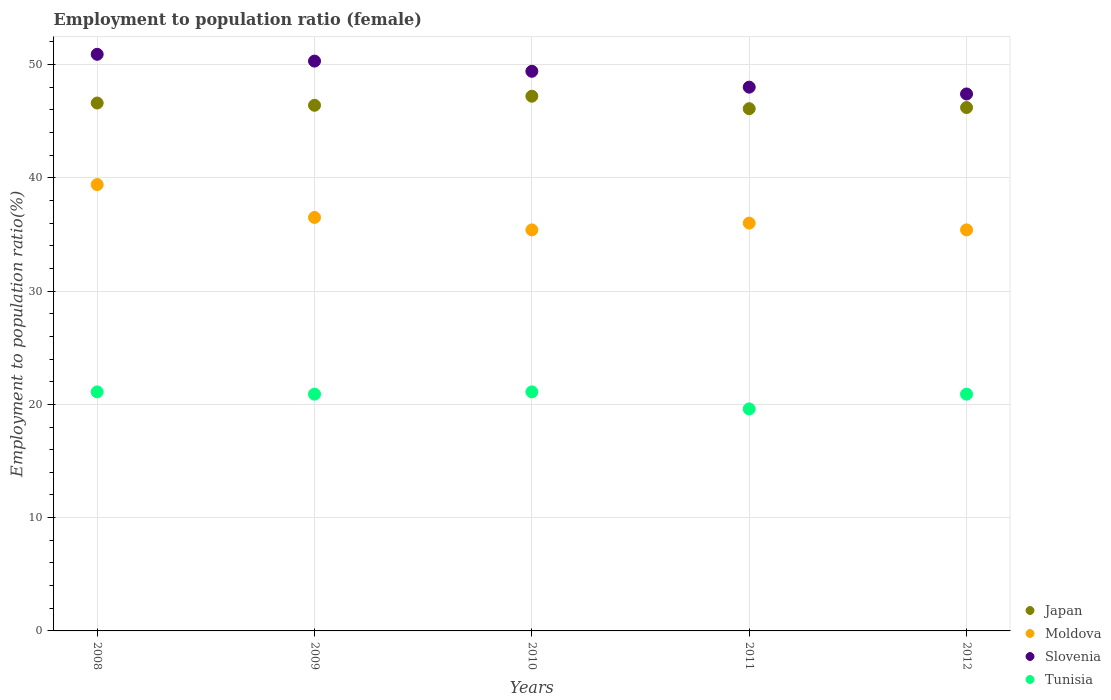What is the employment to population ratio in Slovenia in 2009?
Provide a succinct answer. 50.3. Across all years, what is the maximum employment to population ratio in Tunisia?
Your answer should be very brief. 21.1. Across all years, what is the minimum employment to population ratio in Slovenia?
Your answer should be very brief. 47.4. What is the total employment to population ratio in Moldova in the graph?
Your answer should be very brief. 182.7. What is the difference between the employment to population ratio in Slovenia in 2010 and the employment to population ratio in Japan in 2012?
Ensure brevity in your answer.  3.2. What is the average employment to population ratio in Slovenia per year?
Keep it short and to the point. 49.2. In the year 2011, what is the difference between the employment to population ratio in Japan and employment to population ratio in Slovenia?
Keep it short and to the point. -1.9. What is the ratio of the employment to population ratio in Tunisia in 2008 to that in 2010?
Provide a succinct answer. 1. What is the difference between the highest and the second highest employment to population ratio in Slovenia?
Make the answer very short. 0.6. Is the sum of the employment to population ratio in Slovenia in 2009 and 2011 greater than the maximum employment to population ratio in Japan across all years?
Offer a very short reply. Yes. Is it the case that in every year, the sum of the employment to population ratio in Moldova and employment to population ratio in Tunisia  is greater than the employment to population ratio in Slovenia?
Offer a very short reply. Yes. What is the difference between two consecutive major ticks on the Y-axis?
Ensure brevity in your answer.  10. Does the graph contain any zero values?
Your answer should be compact. No. Where does the legend appear in the graph?
Your response must be concise. Bottom right. What is the title of the graph?
Keep it short and to the point. Employment to population ratio (female). Does "Georgia" appear as one of the legend labels in the graph?
Your answer should be compact. No. What is the label or title of the Y-axis?
Give a very brief answer. Employment to population ratio(%). What is the Employment to population ratio(%) of Japan in 2008?
Provide a succinct answer. 46.6. What is the Employment to population ratio(%) of Moldova in 2008?
Keep it short and to the point. 39.4. What is the Employment to population ratio(%) of Slovenia in 2008?
Make the answer very short. 50.9. What is the Employment to population ratio(%) in Tunisia in 2008?
Keep it short and to the point. 21.1. What is the Employment to population ratio(%) of Japan in 2009?
Keep it short and to the point. 46.4. What is the Employment to population ratio(%) in Moldova in 2009?
Make the answer very short. 36.5. What is the Employment to population ratio(%) of Slovenia in 2009?
Your answer should be compact. 50.3. What is the Employment to population ratio(%) of Tunisia in 2009?
Offer a very short reply. 20.9. What is the Employment to population ratio(%) in Japan in 2010?
Ensure brevity in your answer.  47.2. What is the Employment to population ratio(%) in Moldova in 2010?
Your answer should be compact. 35.4. What is the Employment to population ratio(%) in Slovenia in 2010?
Ensure brevity in your answer.  49.4. What is the Employment to population ratio(%) in Tunisia in 2010?
Ensure brevity in your answer.  21.1. What is the Employment to population ratio(%) in Japan in 2011?
Your answer should be compact. 46.1. What is the Employment to population ratio(%) of Slovenia in 2011?
Give a very brief answer. 48. What is the Employment to population ratio(%) of Tunisia in 2011?
Offer a terse response. 19.6. What is the Employment to population ratio(%) of Japan in 2012?
Offer a terse response. 46.2. What is the Employment to population ratio(%) in Moldova in 2012?
Keep it short and to the point. 35.4. What is the Employment to population ratio(%) in Slovenia in 2012?
Your response must be concise. 47.4. What is the Employment to population ratio(%) in Tunisia in 2012?
Offer a very short reply. 20.9. Across all years, what is the maximum Employment to population ratio(%) of Japan?
Make the answer very short. 47.2. Across all years, what is the maximum Employment to population ratio(%) in Moldova?
Ensure brevity in your answer.  39.4. Across all years, what is the maximum Employment to population ratio(%) in Slovenia?
Keep it short and to the point. 50.9. Across all years, what is the maximum Employment to population ratio(%) in Tunisia?
Your answer should be compact. 21.1. Across all years, what is the minimum Employment to population ratio(%) of Japan?
Your answer should be compact. 46.1. Across all years, what is the minimum Employment to population ratio(%) in Moldova?
Ensure brevity in your answer.  35.4. Across all years, what is the minimum Employment to population ratio(%) in Slovenia?
Provide a succinct answer. 47.4. Across all years, what is the minimum Employment to population ratio(%) of Tunisia?
Offer a terse response. 19.6. What is the total Employment to population ratio(%) in Japan in the graph?
Give a very brief answer. 232.5. What is the total Employment to population ratio(%) of Moldova in the graph?
Provide a short and direct response. 182.7. What is the total Employment to population ratio(%) in Slovenia in the graph?
Provide a short and direct response. 246. What is the total Employment to population ratio(%) in Tunisia in the graph?
Offer a very short reply. 103.6. What is the difference between the Employment to population ratio(%) in Moldova in 2008 and that in 2009?
Make the answer very short. 2.9. What is the difference between the Employment to population ratio(%) of Tunisia in 2008 and that in 2009?
Your response must be concise. 0.2. What is the difference between the Employment to population ratio(%) of Moldova in 2008 and that in 2010?
Your answer should be very brief. 4. What is the difference between the Employment to population ratio(%) in Slovenia in 2008 and that in 2010?
Provide a short and direct response. 1.5. What is the difference between the Employment to population ratio(%) in Moldova in 2008 and that in 2011?
Provide a succinct answer. 3.4. What is the difference between the Employment to population ratio(%) in Moldova in 2009 and that in 2010?
Offer a terse response. 1.1. What is the difference between the Employment to population ratio(%) of Moldova in 2009 and that in 2011?
Give a very brief answer. 0.5. What is the difference between the Employment to population ratio(%) in Slovenia in 2009 and that in 2011?
Ensure brevity in your answer.  2.3. What is the difference between the Employment to population ratio(%) of Tunisia in 2009 and that in 2011?
Ensure brevity in your answer.  1.3. What is the difference between the Employment to population ratio(%) of Moldova in 2009 and that in 2012?
Offer a terse response. 1.1. What is the difference between the Employment to population ratio(%) of Slovenia in 2009 and that in 2012?
Keep it short and to the point. 2.9. What is the difference between the Employment to population ratio(%) in Tunisia in 2009 and that in 2012?
Your response must be concise. 0. What is the difference between the Employment to population ratio(%) in Japan in 2010 and that in 2011?
Make the answer very short. 1.1. What is the difference between the Employment to population ratio(%) in Moldova in 2010 and that in 2011?
Give a very brief answer. -0.6. What is the difference between the Employment to population ratio(%) of Slovenia in 2010 and that in 2011?
Provide a succinct answer. 1.4. What is the difference between the Employment to population ratio(%) in Slovenia in 2010 and that in 2012?
Provide a succinct answer. 2. What is the difference between the Employment to population ratio(%) of Tunisia in 2010 and that in 2012?
Keep it short and to the point. 0.2. What is the difference between the Employment to population ratio(%) in Japan in 2011 and that in 2012?
Make the answer very short. -0.1. What is the difference between the Employment to population ratio(%) in Japan in 2008 and the Employment to population ratio(%) in Moldova in 2009?
Give a very brief answer. 10.1. What is the difference between the Employment to population ratio(%) of Japan in 2008 and the Employment to population ratio(%) of Tunisia in 2009?
Offer a very short reply. 25.7. What is the difference between the Employment to population ratio(%) in Moldova in 2008 and the Employment to population ratio(%) in Tunisia in 2009?
Your response must be concise. 18.5. What is the difference between the Employment to population ratio(%) in Slovenia in 2008 and the Employment to population ratio(%) in Tunisia in 2009?
Ensure brevity in your answer.  30. What is the difference between the Employment to population ratio(%) in Japan in 2008 and the Employment to population ratio(%) in Slovenia in 2010?
Offer a very short reply. -2.8. What is the difference between the Employment to population ratio(%) of Japan in 2008 and the Employment to population ratio(%) of Tunisia in 2010?
Offer a very short reply. 25.5. What is the difference between the Employment to population ratio(%) of Moldova in 2008 and the Employment to population ratio(%) of Tunisia in 2010?
Make the answer very short. 18.3. What is the difference between the Employment to population ratio(%) of Slovenia in 2008 and the Employment to population ratio(%) of Tunisia in 2010?
Your answer should be compact. 29.8. What is the difference between the Employment to population ratio(%) of Japan in 2008 and the Employment to population ratio(%) of Moldova in 2011?
Your response must be concise. 10.6. What is the difference between the Employment to population ratio(%) of Japan in 2008 and the Employment to population ratio(%) of Slovenia in 2011?
Ensure brevity in your answer.  -1.4. What is the difference between the Employment to population ratio(%) in Japan in 2008 and the Employment to population ratio(%) in Tunisia in 2011?
Your answer should be compact. 27. What is the difference between the Employment to population ratio(%) in Moldova in 2008 and the Employment to population ratio(%) in Tunisia in 2011?
Keep it short and to the point. 19.8. What is the difference between the Employment to population ratio(%) of Slovenia in 2008 and the Employment to population ratio(%) of Tunisia in 2011?
Offer a terse response. 31.3. What is the difference between the Employment to population ratio(%) of Japan in 2008 and the Employment to population ratio(%) of Slovenia in 2012?
Offer a very short reply. -0.8. What is the difference between the Employment to population ratio(%) in Japan in 2008 and the Employment to population ratio(%) in Tunisia in 2012?
Ensure brevity in your answer.  25.7. What is the difference between the Employment to population ratio(%) of Moldova in 2008 and the Employment to population ratio(%) of Slovenia in 2012?
Your answer should be compact. -8. What is the difference between the Employment to population ratio(%) of Moldova in 2008 and the Employment to population ratio(%) of Tunisia in 2012?
Give a very brief answer. 18.5. What is the difference between the Employment to population ratio(%) in Slovenia in 2008 and the Employment to population ratio(%) in Tunisia in 2012?
Ensure brevity in your answer.  30. What is the difference between the Employment to population ratio(%) of Japan in 2009 and the Employment to population ratio(%) of Slovenia in 2010?
Provide a succinct answer. -3. What is the difference between the Employment to population ratio(%) of Japan in 2009 and the Employment to population ratio(%) of Tunisia in 2010?
Provide a short and direct response. 25.3. What is the difference between the Employment to population ratio(%) of Moldova in 2009 and the Employment to population ratio(%) of Tunisia in 2010?
Provide a succinct answer. 15.4. What is the difference between the Employment to population ratio(%) of Slovenia in 2009 and the Employment to population ratio(%) of Tunisia in 2010?
Ensure brevity in your answer.  29.2. What is the difference between the Employment to population ratio(%) in Japan in 2009 and the Employment to population ratio(%) in Slovenia in 2011?
Your answer should be compact. -1.6. What is the difference between the Employment to population ratio(%) in Japan in 2009 and the Employment to population ratio(%) in Tunisia in 2011?
Offer a terse response. 26.8. What is the difference between the Employment to population ratio(%) of Moldova in 2009 and the Employment to population ratio(%) of Slovenia in 2011?
Provide a short and direct response. -11.5. What is the difference between the Employment to population ratio(%) of Moldova in 2009 and the Employment to population ratio(%) of Tunisia in 2011?
Your response must be concise. 16.9. What is the difference between the Employment to population ratio(%) of Slovenia in 2009 and the Employment to population ratio(%) of Tunisia in 2011?
Give a very brief answer. 30.7. What is the difference between the Employment to population ratio(%) in Japan in 2009 and the Employment to population ratio(%) in Slovenia in 2012?
Your answer should be very brief. -1. What is the difference between the Employment to population ratio(%) of Japan in 2009 and the Employment to population ratio(%) of Tunisia in 2012?
Offer a terse response. 25.5. What is the difference between the Employment to population ratio(%) of Moldova in 2009 and the Employment to population ratio(%) of Slovenia in 2012?
Give a very brief answer. -10.9. What is the difference between the Employment to population ratio(%) in Slovenia in 2009 and the Employment to population ratio(%) in Tunisia in 2012?
Your response must be concise. 29.4. What is the difference between the Employment to population ratio(%) of Japan in 2010 and the Employment to population ratio(%) of Moldova in 2011?
Give a very brief answer. 11.2. What is the difference between the Employment to population ratio(%) in Japan in 2010 and the Employment to population ratio(%) in Slovenia in 2011?
Provide a succinct answer. -0.8. What is the difference between the Employment to population ratio(%) of Japan in 2010 and the Employment to population ratio(%) of Tunisia in 2011?
Offer a terse response. 27.6. What is the difference between the Employment to population ratio(%) in Slovenia in 2010 and the Employment to population ratio(%) in Tunisia in 2011?
Make the answer very short. 29.8. What is the difference between the Employment to population ratio(%) in Japan in 2010 and the Employment to population ratio(%) in Tunisia in 2012?
Your response must be concise. 26.3. What is the difference between the Employment to population ratio(%) of Moldova in 2010 and the Employment to population ratio(%) of Slovenia in 2012?
Give a very brief answer. -12. What is the difference between the Employment to population ratio(%) in Slovenia in 2010 and the Employment to population ratio(%) in Tunisia in 2012?
Provide a short and direct response. 28.5. What is the difference between the Employment to population ratio(%) of Japan in 2011 and the Employment to population ratio(%) of Tunisia in 2012?
Provide a succinct answer. 25.2. What is the difference between the Employment to population ratio(%) in Moldova in 2011 and the Employment to population ratio(%) in Slovenia in 2012?
Offer a very short reply. -11.4. What is the difference between the Employment to population ratio(%) of Moldova in 2011 and the Employment to population ratio(%) of Tunisia in 2012?
Your answer should be very brief. 15.1. What is the difference between the Employment to population ratio(%) of Slovenia in 2011 and the Employment to population ratio(%) of Tunisia in 2012?
Ensure brevity in your answer.  27.1. What is the average Employment to population ratio(%) of Japan per year?
Offer a very short reply. 46.5. What is the average Employment to population ratio(%) of Moldova per year?
Your answer should be very brief. 36.54. What is the average Employment to population ratio(%) of Slovenia per year?
Provide a short and direct response. 49.2. What is the average Employment to population ratio(%) in Tunisia per year?
Give a very brief answer. 20.72. In the year 2008, what is the difference between the Employment to population ratio(%) in Japan and Employment to population ratio(%) in Moldova?
Your answer should be very brief. 7.2. In the year 2008, what is the difference between the Employment to population ratio(%) of Japan and Employment to population ratio(%) of Tunisia?
Give a very brief answer. 25.5. In the year 2008, what is the difference between the Employment to population ratio(%) in Slovenia and Employment to population ratio(%) in Tunisia?
Offer a very short reply. 29.8. In the year 2009, what is the difference between the Employment to population ratio(%) in Japan and Employment to population ratio(%) in Moldova?
Your answer should be very brief. 9.9. In the year 2009, what is the difference between the Employment to population ratio(%) in Japan and Employment to population ratio(%) in Slovenia?
Make the answer very short. -3.9. In the year 2009, what is the difference between the Employment to population ratio(%) of Moldova and Employment to population ratio(%) of Slovenia?
Ensure brevity in your answer.  -13.8. In the year 2009, what is the difference between the Employment to population ratio(%) in Slovenia and Employment to population ratio(%) in Tunisia?
Keep it short and to the point. 29.4. In the year 2010, what is the difference between the Employment to population ratio(%) in Japan and Employment to population ratio(%) in Slovenia?
Offer a terse response. -2.2. In the year 2010, what is the difference between the Employment to population ratio(%) of Japan and Employment to population ratio(%) of Tunisia?
Provide a short and direct response. 26.1. In the year 2010, what is the difference between the Employment to population ratio(%) of Slovenia and Employment to population ratio(%) of Tunisia?
Offer a terse response. 28.3. In the year 2011, what is the difference between the Employment to population ratio(%) of Japan and Employment to population ratio(%) of Slovenia?
Your answer should be very brief. -1.9. In the year 2011, what is the difference between the Employment to population ratio(%) in Japan and Employment to population ratio(%) in Tunisia?
Give a very brief answer. 26.5. In the year 2011, what is the difference between the Employment to population ratio(%) of Moldova and Employment to population ratio(%) of Slovenia?
Ensure brevity in your answer.  -12. In the year 2011, what is the difference between the Employment to population ratio(%) in Moldova and Employment to population ratio(%) in Tunisia?
Ensure brevity in your answer.  16.4. In the year 2011, what is the difference between the Employment to population ratio(%) of Slovenia and Employment to population ratio(%) of Tunisia?
Your response must be concise. 28.4. In the year 2012, what is the difference between the Employment to population ratio(%) in Japan and Employment to population ratio(%) in Moldova?
Offer a very short reply. 10.8. In the year 2012, what is the difference between the Employment to population ratio(%) of Japan and Employment to population ratio(%) of Slovenia?
Make the answer very short. -1.2. In the year 2012, what is the difference between the Employment to population ratio(%) in Japan and Employment to population ratio(%) in Tunisia?
Keep it short and to the point. 25.3. In the year 2012, what is the difference between the Employment to population ratio(%) in Moldova and Employment to population ratio(%) in Tunisia?
Your response must be concise. 14.5. In the year 2012, what is the difference between the Employment to population ratio(%) of Slovenia and Employment to population ratio(%) of Tunisia?
Offer a very short reply. 26.5. What is the ratio of the Employment to population ratio(%) in Moldova in 2008 to that in 2009?
Keep it short and to the point. 1.08. What is the ratio of the Employment to population ratio(%) of Slovenia in 2008 to that in 2009?
Your response must be concise. 1.01. What is the ratio of the Employment to population ratio(%) in Tunisia in 2008 to that in 2009?
Make the answer very short. 1.01. What is the ratio of the Employment to population ratio(%) in Japan in 2008 to that in 2010?
Keep it short and to the point. 0.99. What is the ratio of the Employment to population ratio(%) of Moldova in 2008 to that in 2010?
Your answer should be very brief. 1.11. What is the ratio of the Employment to population ratio(%) of Slovenia in 2008 to that in 2010?
Ensure brevity in your answer.  1.03. What is the ratio of the Employment to population ratio(%) of Japan in 2008 to that in 2011?
Give a very brief answer. 1.01. What is the ratio of the Employment to population ratio(%) in Moldova in 2008 to that in 2011?
Your answer should be very brief. 1.09. What is the ratio of the Employment to population ratio(%) in Slovenia in 2008 to that in 2011?
Your response must be concise. 1.06. What is the ratio of the Employment to population ratio(%) of Tunisia in 2008 to that in 2011?
Provide a short and direct response. 1.08. What is the ratio of the Employment to population ratio(%) of Japan in 2008 to that in 2012?
Ensure brevity in your answer.  1.01. What is the ratio of the Employment to population ratio(%) of Moldova in 2008 to that in 2012?
Offer a terse response. 1.11. What is the ratio of the Employment to population ratio(%) in Slovenia in 2008 to that in 2012?
Ensure brevity in your answer.  1.07. What is the ratio of the Employment to population ratio(%) in Tunisia in 2008 to that in 2012?
Your answer should be very brief. 1.01. What is the ratio of the Employment to population ratio(%) in Japan in 2009 to that in 2010?
Your answer should be very brief. 0.98. What is the ratio of the Employment to population ratio(%) in Moldova in 2009 to that in 2010?
Your response must be concise. 1.03. What is the ratio of the Employment to population ratio(%) in Slovenia in 2009 to that in 2010?
Provide a succinct answer. 1.02. What is the ratio of the Employment to population ratio(%) in Tunisia in 2009 to that in 2010?
Provide a succinct answer. 0.99. What is the ratio of the Employment to population ratio(%) in Japan in 2009 to that in 2011?
Ensure brevity in your answer.  1.01. What is the ratio of the Employment to population ratio(%) in Moldova in 2009 to that in 2011?
Your answer should be very brief. 1.01. What is the ratio of the Employment to population ratio(%) in Slovenia in 2009 to that in 2011?
Offer a terse response. 1.05. What is the ratio of the Employment to population ratio(%) of Tunisia in 2009 to that in 2011?
Your answer should be very brief. 1.07. What is the ratio of the Employment to population ratio(%) in Japan in 2009 to that in 2012?
Offer a terse response. 1. What is the ratio of the Employment to population ratio(%) in Moldova in 2009 to that in 2012?
Offer a very short reply. 1.03. What is the ratio of the Employment to population ratio(%) of Slovenia in 2009 to that in 2012?
Your answer should be very brief. 1.06. What is the ratio of the Employment to population ratio(%) in Tunisia in 2009 to that in 2012?
Your answer should be very brief. 1. What is the ratio of the Employment to population ratio(%) in Japan in 2010 to that in 2011?
Your response must be concise. 1.02. What is the ratio of the Employment to population ratio(%) in Moldova in 2010 to that in 2011?
Your answer should be compact. 0.98. What is the ratio of the Employment to population ratio(%) in Slovenia in 2010 to that in 2011?
Ensure brevity in your answer.  1.03. What is the ratio of the Employment to population ratio(%) of Tunisia in 2010 to that in 2011?
Your answer should be compact. 1.08. What is the ratio of the Employment to population ratio(%) in Japan in 2010 to that in 2012?
Make the answer very short. 1.02. What is the ratio of the Employment to population ratio(%) of Moldova in 2010 to that in 2012?
Offer a very short reply. 1. What is the ratio of the Employment to population ratio(%) of Slovenia in 2010 to that in 2012?
Offer a terse response. 1.04. What is the ratio of the Employment to population ratio(%) in Tunisia in 2010 to that in 2012?
Ensure brevity in your answer.  1.01. What is the ratio of the Employment to population ratio(%) in Moldova in 2011 to that in 2012?
Make the answer very short. 1.02. What is the ratio of the Employment to population ratio(%) of Slovenia in 2011 to that in 2012?
Provide a succinct answer. 1.01. What is the ratio of the Employment to population ratio(%) in Tunisia in 2011 to that in 2012?
Offer a terse response. 0.94. What is the difference between the highest and the second highest Employment to population ratio(%) in Japan?
Make the answer very short. 0.6. What is the difference between the highest and the second highest Employment to population ratio(%) of Moldova?
Your answer should be compact. 2.9. 